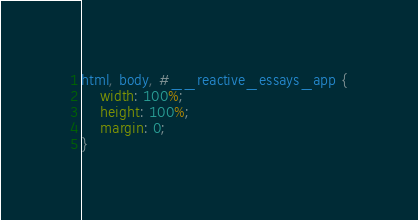<code> <loc_0><loc_0><loc_500><loc_500><_CSS_>html, body, #__reactive_essays_app {
	width: 100%;
	height: 100%;
	margin: 0;
}</code> 